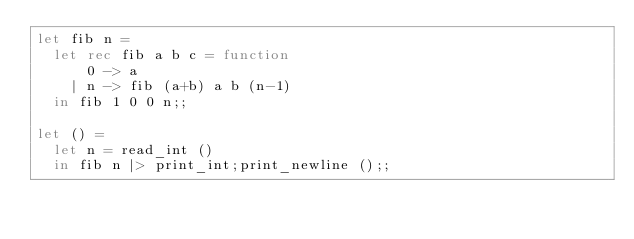Convert code to text. <code><loc_0><loc_0><loc_500><loc_500><_OCaml_>let fib n =
  let rec fib a b c = function
      0 -> a
    | n -> fib (a+b) a b (n-1)
  in fib 1 0 0 n;;

let () =
  let n = read_int ()
  in fib n |> print_int;print_newline ();;</code> 